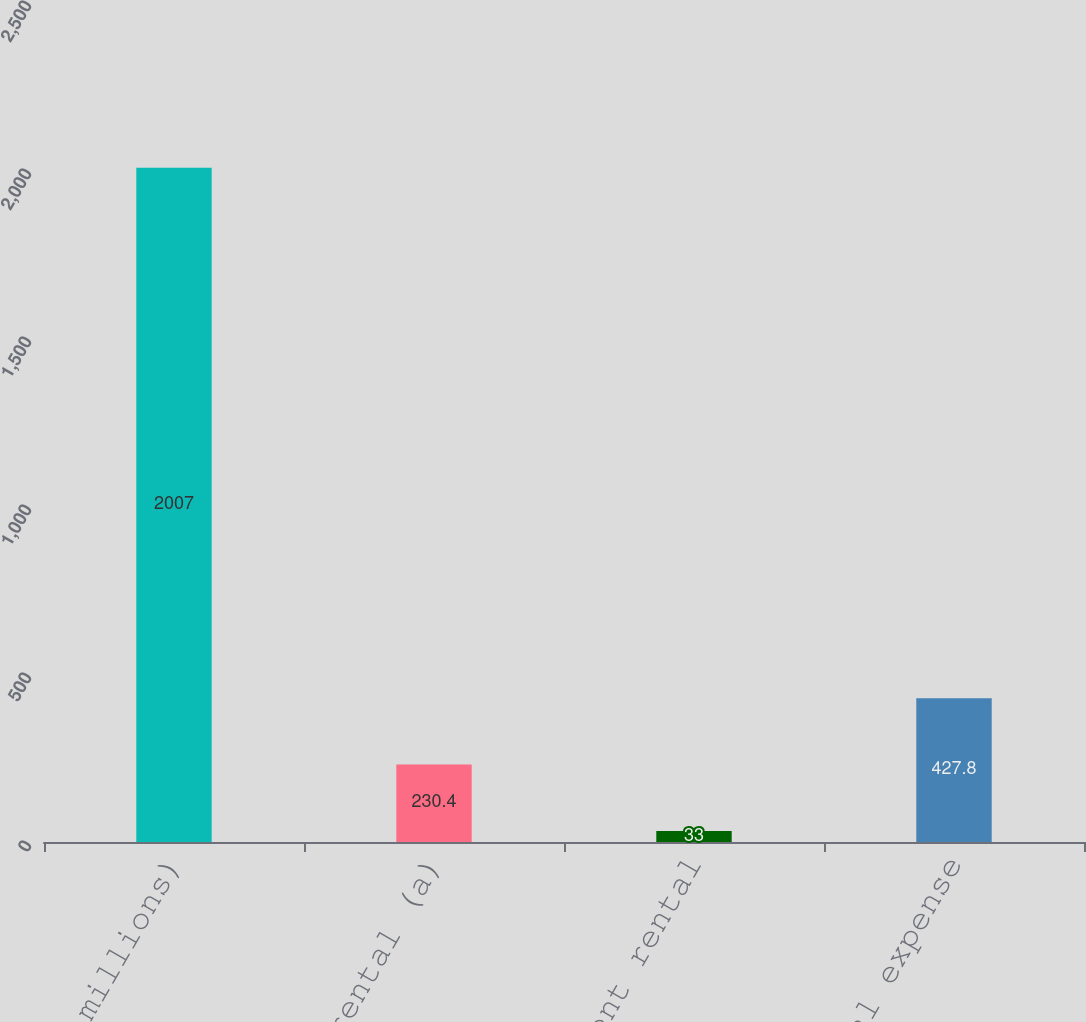Convert chart to OTSL. <chart><loc_0><loc_0><loc_500><loc_500><bar_chart><fcel>(In millions)<fcel>Minimum rental (a)<fcel>Contingent rental<fcel>Net rental expense<nl><fcel>2007<fcel>230.4<fcel>33<fcel>427.8<nl></chart> 